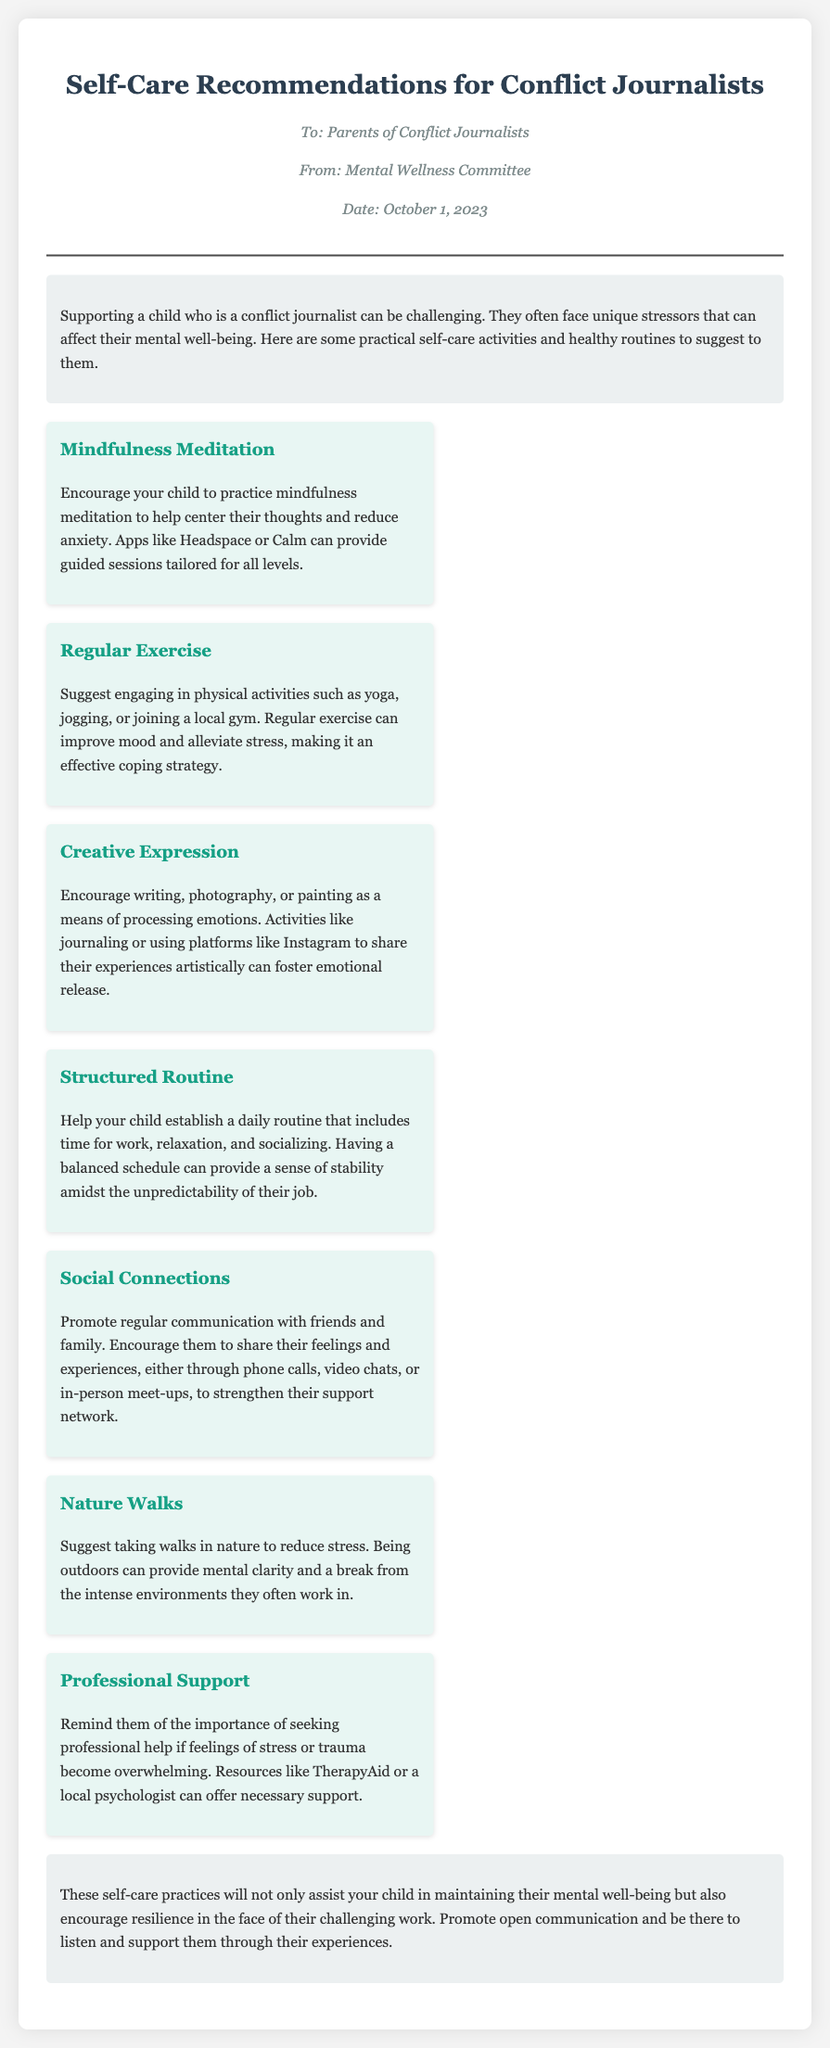What is the title of the document? The title is stated at the top of the memo, providing the main subject of the content.
Answer: Self-Care Recommendations for Conflict Journalists Who is the memo addressed to? The recipient of the memo is indicated in the header section.
Answer: Parents of Conflict Journalists What organization is mentioned as the source of the memo? The source or author of the memo is specified in the meta section.
Answer: Mental Wellness Committee What is one self-care recommendation provided? The memo lists various self-care suggestions for conflict journalists, summarizing the content effectively.
Answer: Mindfulness Meditation How many self-care activities are suggested in the document? The total number of activities listed can be counted within the recommendations section.
Answer: Seven What is the date mentioned in the memo? The document includes a date indicating when it was created or sent.
Answer: October 1, 2023 What type of support does the memo recommend seeking? The memo emphasizes the necessity of including certain professional assistance in the recommendations.
Answer: Professional Support What is one benefit of regular exercise mentioned? The memo describes positive effects of certain activities on mental well-being.
Answer: Improve mood What does the introduction highlight about supporting conflict journalists? The introduction clarifies the challenges faced in supporting individuals in this profession.
Answer: Unique stressors 